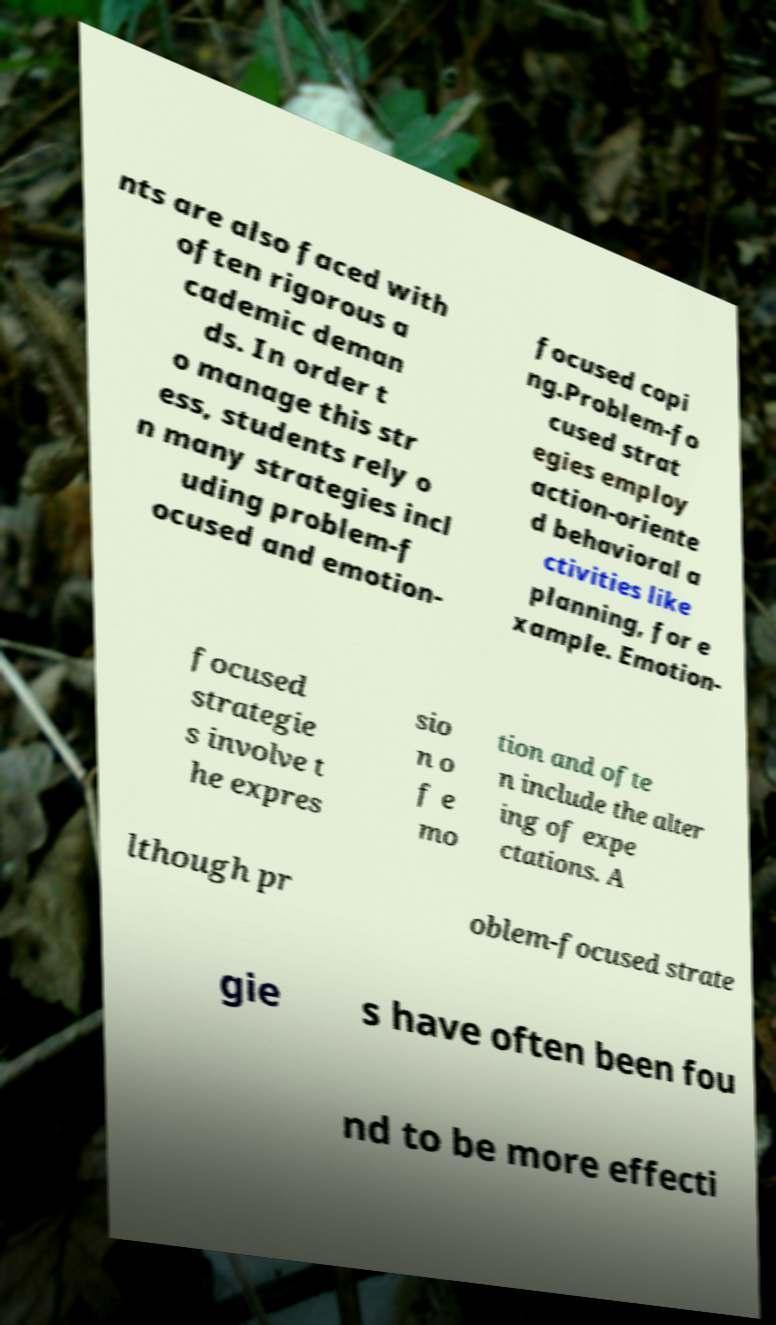I need the written content from this picture converted into text. Can you do that? nts are also faced with often rigorous a cademic deman ds. In order t o manage this str ess, students rely o n many strategies incl uding problem-f ocused and emotion- focused copi ng.Problem-fo cused strat egies employ action-oriente d behavioral a ctivities like planning, for e xample. Emotion- focused strategie s involve t he expres sio n o f e mo tion and ofte n include the alter ing of expe ctations. A lthough pr oblem-focused strate gie s have often been fou nd to be more effecti 